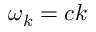<formula> <loc_0><loc_0><loc_500><loc_500>\omega _ { k } = c k</formula> 